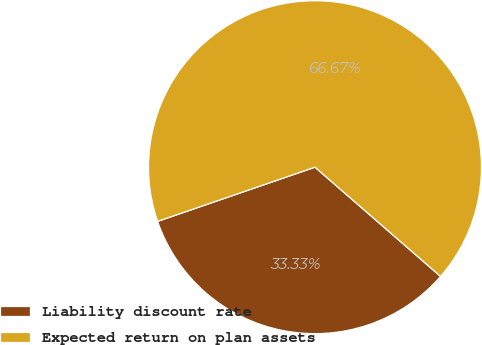Convert chart. <chart><loc_0><loc_0><loc_500><loc_500><pie_chart><fcel>Liability discount rate<fcel>Expected return on plan assets<nl><fcel>33.33%<fcel>66.67%<nl></chart> 